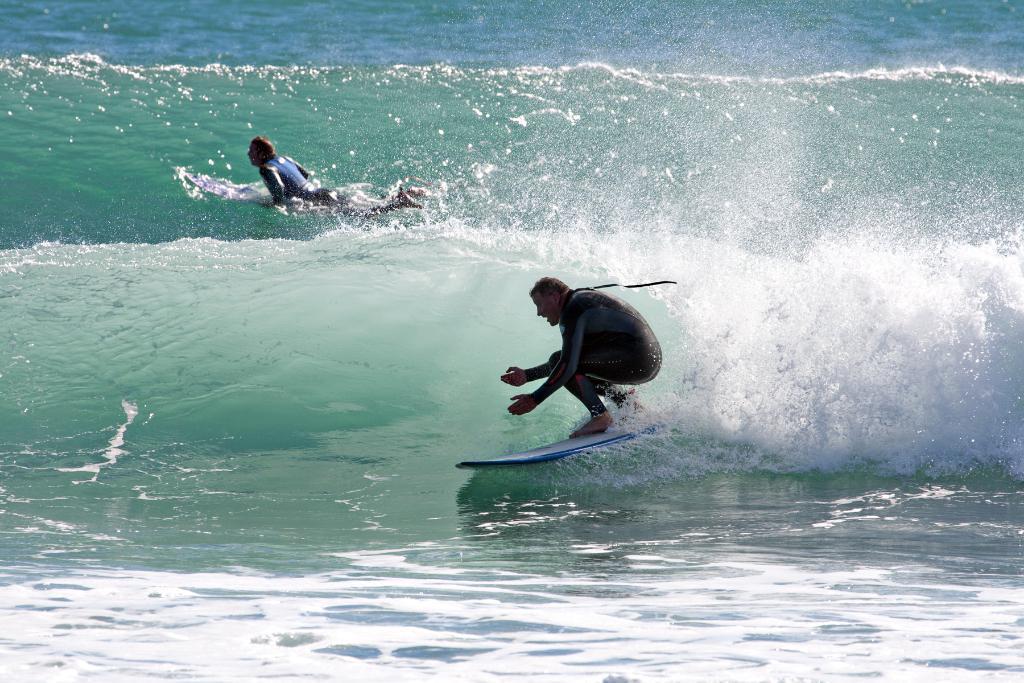Can you describe this image briefly? This picture is clicked outside the city. In the center we can see the two persons surfing on the surf port and we can see the ripples in the water body. 